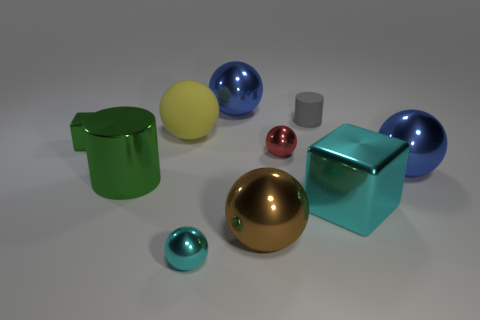Subtract all cyan spheres. How many spheres are left? 5 Subtract all big yellow spheres. How many spheres are left? 5 Subtract 2 spheres. How many spheres are left? 4 Subtract all purple balls. Subtract all purple cubes. How many balls are left? 6 Subtract all cubes. How many objects are left? 8 Subtract all large yellow rubber things. Subtract all yellow matte things. How many objects are left? 8 Add 4 cubes. How many cubes are left? 6 Add 6 green matte blocks. How many green matte blocks exist? 6 Subtract 0 purple cubes. How many objects are left? 10 